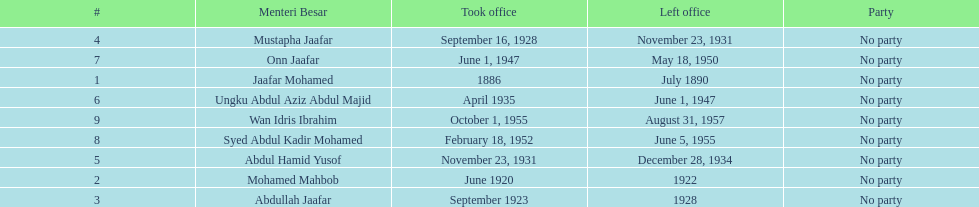How long did ungku abdul aziz abdul majid serve? 12 years. 